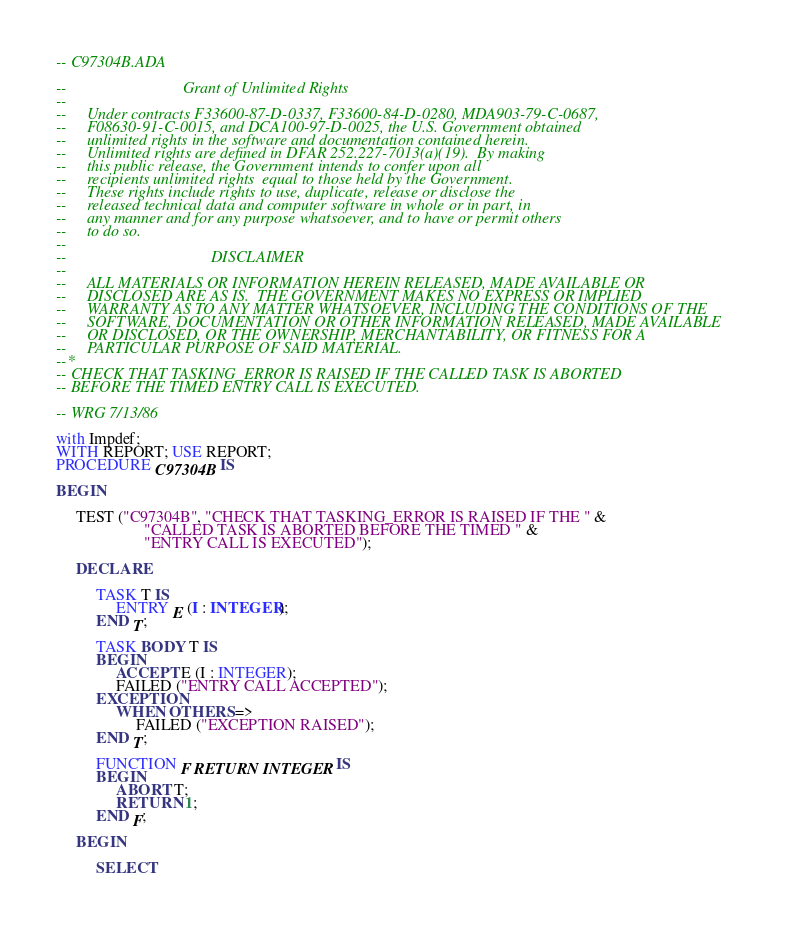<code> <loc_0><loc_0><loc_500><loc_500><_Ada_>-- C97304B.ADA

--                             Grant of Unlimited Rights
--
--     Under contracts F33600-87-D-0337, F33600-84-D-0280, MDA903-79-C-0687,
--     F08630-91-C-0015, and DCA100-97-D-0025, the U.S. Government obtained 
--     unlimited rights in the software and documentation contained herein.
--     Unlimited rights are defined in DFAR 252.227-7013(a)(19).  By making 
--     this public release, the Government intends to confer upon all 
--     recipients unlimited rights  equal to those held by the Government.  
--     These rights include rights to use, duplicate, release or disclose the 
--     released technical data and computer software in whole or in part, in 
--     any manner and for any purpose whatsoever, and to have or permit others 
--     to do so.
--
--                                    DISCLAIMER
--
--     ALL MATERIALS OR INFORMATION HEREIN RELEASED, MADE AVAILABLE OR
--     DISCLOSED ARE AS IS.  THE GOVERNMENT MAKES NO EXPRESS OR IMPLIED 
--     WARRANTY AS TO ANY MATTER WHATSOEVER, INCLUDING THE CONDITIONS OF THE
--     SOFTWARE, DOCUMENTATION OR OTHER INFORMATION RELEASED, MADE AVAILABLE 
--     OR DISCLOSED, OR THE OWNERSHIP, MERCHANTABILITY, OR FITNESS FOR A
--     PARTICULAR PURPOSE OF SAID MATERIAL.
--*
-- CHECK THAT TASKING_ERROR IS RAISED IF THE CALLED TASK IS ABORTED
-- BEFORE THE TIMED ENTRY CALL IS EXECUTED.

-- WRG 7/13/86

with Impdef;
WITH REPORT; USE REPORT;
PROCEDURE C97304B IS

BEGIN

     TEST ("C97304B", "CHECK THAT TASKING_ERROR IS RAISED IF THE " &
                      "CALLED TASK IS ABORTED BEFORE THE TIMED " &
                      "ENTRY CALL IS EXECUTED");

     DECLARE

          TASK T IS
               ENTRY E (I : INTEGER);
          END T;

          TASK BODY T IS
          BEGIN
               ACCEPT E (I : INTEGER);
               FAILED ("ENTRY CALL ACCEPTED");
          EXCEPTION
               WHEN OTHERS =>
                    FAILED ("EXCEPTION RAISED");
          END T;

          FUNCTION F RETURN INTEGER IS
          BEGIN
               ABORT T;
               RETURN 1;
          END F;

     BEGIN

          SELECT</code> 